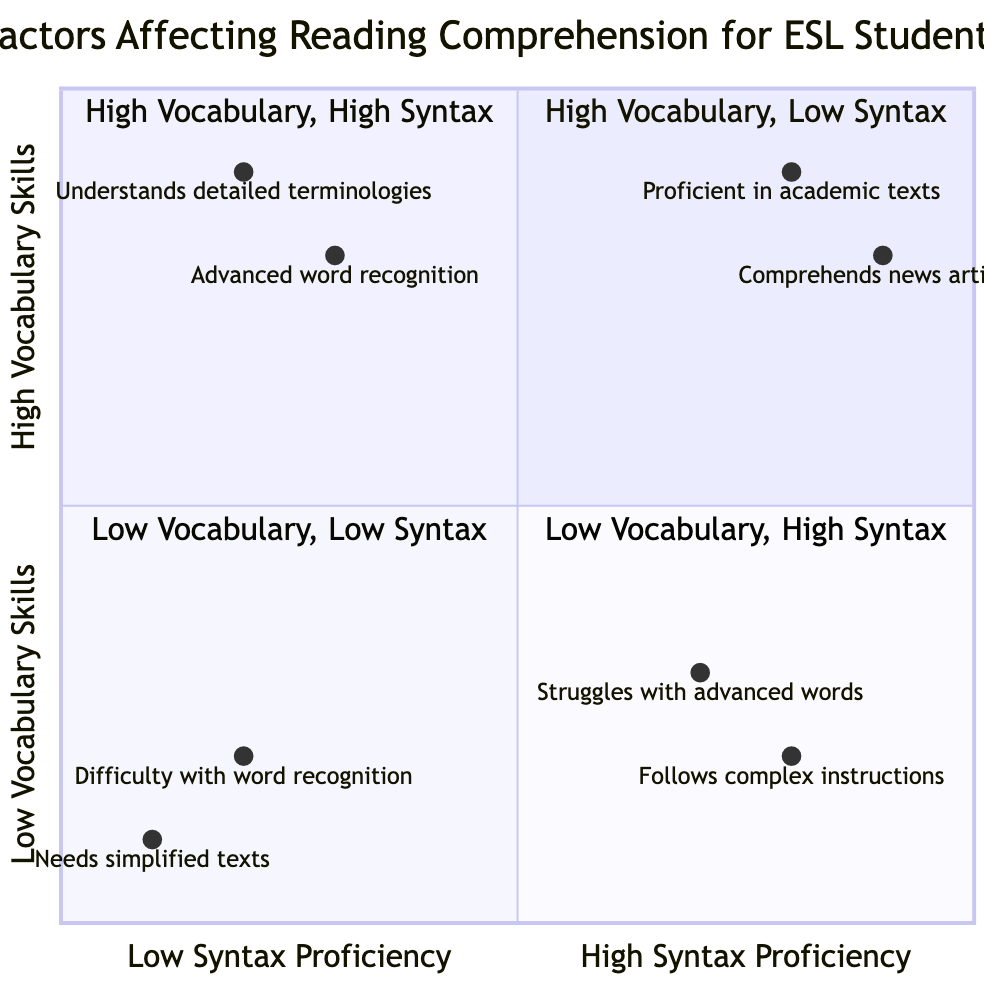What are the titles of the quadrants in the diagram? The titles of the quadrants are listed as follows: Top-Left: "High Vocabulary, Low Syntax", Top-Right: "High Vocabulary, High Syntax", Bottom-Left: "Low Vocabulary, Low Syntax", Bottom-Right: "Low Vocabulary, High Syntax".
Answer: High Vocabulary, Low Syntax; High Vocabulary, High Syntax; Low Vocabulary, Low Syntax; Low Vocabulary, High Syntax Which quadrant contains students who can easily understand news articles? The quadrant that describes students who can easily understand news articles is the Top-Right quadrant, which indicates "High Vocabulary, High Syntax".
Answer: High Vocabulary, High Syntax How many example entities are listed in the Bottom-Left quadrant? The Bottom-Left quadrant contains two example entities: "Example 1" and "Example 2".
Answer: 2 In which quadrant do students struggle with both word recognition and sentence parsing? Students that struggle with both word recognition and sentence parsing are found in the Bottom-Left quadrant, indicated by "Low Vocabulary, Low Syntax".
Answer: Low Vocabulary, Low Syntax What characteristic is common among students in the Top-Left quadrant? Students in the Top-Left quadrant possess advanced word recognition but have difficulty with complex sentence structures. This is summarized by "High Vocabulary, Low Syntax".
Answer: High Vocabulary, Low Syntax Which example entity in the Bottom-Right quadrant describes students managing to understand sentence context? The example entity in the Bottom-Right quadrant that describes this characteristic is "Example 1," which states, "Struggles with advanced words but manages to understand sentence context."
Answer: Example 1 Which quadrant includes students who understands detailed terminologies but get confused with subordinate clauses? The students who understand detailed terminologies but get confused with subordinate clauses fall into the Top-Left quadrant, characterized by "High Vocabulary, Low Syntax".
Answer: High Vocabulary, Low Syntax How many quadrants feature students with low vocabulary skills? There are two quadrants that feature students with low vocabulary skills: Bottom-Left ("Low Vocabulary, Low Syntax") and Bottom-Right ("Low Vocabulary, High Syntax").
Answer: 2 